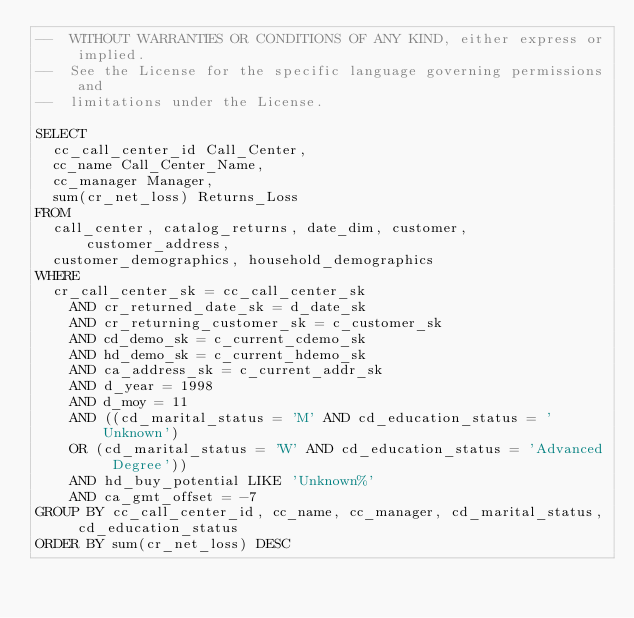<code> <loc_0><loc_0><loc_500><loc_500><_SQL_>--  WITHOUT WARRANTIES OR CONDITIONS OF ANY KIND, either express or implied.
--  See the License for the specific language governing permissions and
--  limitations under the License.

SELECT
  cc_call_center_id Call_Center,
  cc_name Call_Center_Name,
  cc_manager Manager,
  sum(cr_net_loss) Returns_Loss
FROM
  call_center, catalog_returns, date_dim, customer, customer_address,
  customer_demographics, household_demographics
WHERE
  cr_call_center_sk = cc_call_center_sk
    AND cr_returned_date_sk = d_date_sk
    AND cr_returning_customer_sk = c_customer_sk
    AND cd_demo_sk = c_current_cdemo_sk
    AND hd_demo_sk = c_current_hdemo_sk
    AND ca_address_sk = c_current_addr_sk
    AND d_year = 1998
    AND d_moy = 11
    AND ((cd_marital_status = 'M' AND cd_education_status = 'Unknown')
    OR (cd_marital_status = 'W' AND cd_education_status = 'Advanced Degree'))
    AND hd_buy_potential LIKE 'Unknown%'
    AND ca_gmt_offset = -7
GROUP BY cc_call_center_id, cc_name, cc_manager, cd_marital_status, cd_education_status
ORDER BY sum(cr_net_loss) DESC
</code> 